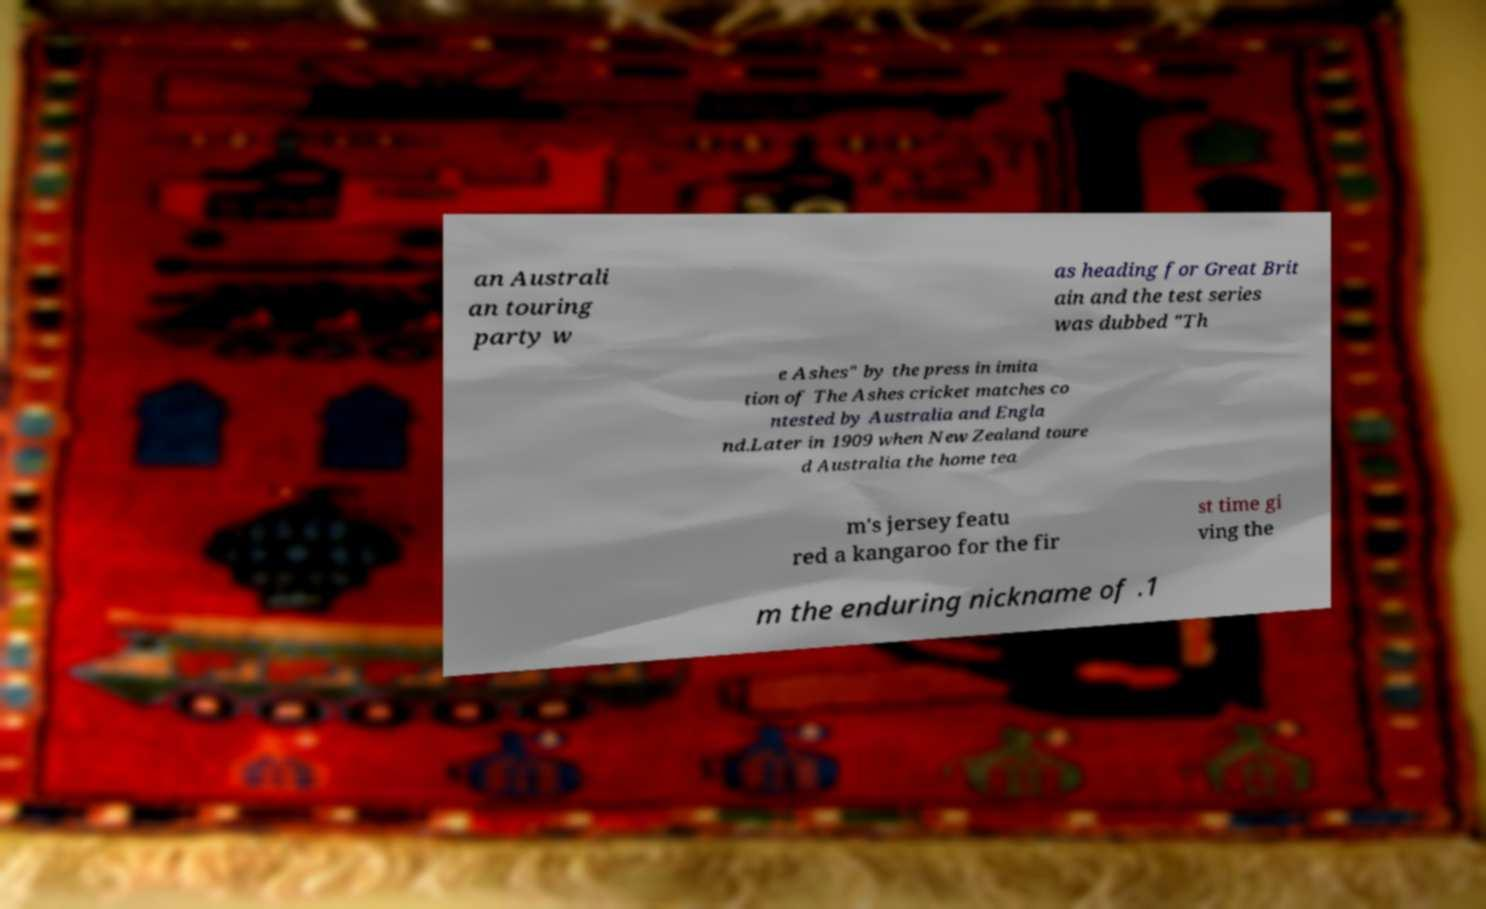Could you extract and type out the text from this image? an Australi an touring party w as heading for Great Brit ain and the test series was dubbed "Th e Ashes" by the press in imita tion of The Ashes cricket matches co ntested by Australia and Engla nd.Later in 1909 when New Zealand toure d Australia the home tea m's jersey featu red a kangaroo for the fir st time gi ving the m the enduring nickname of .1 